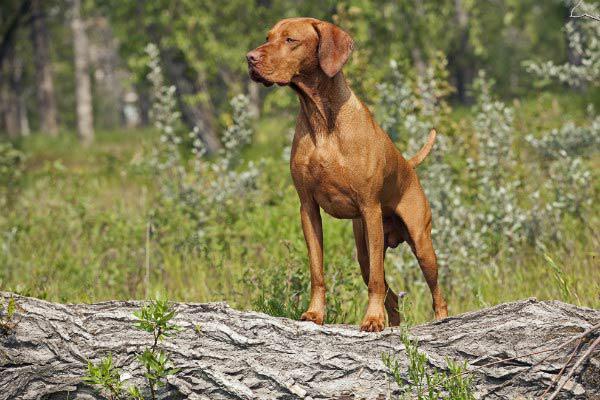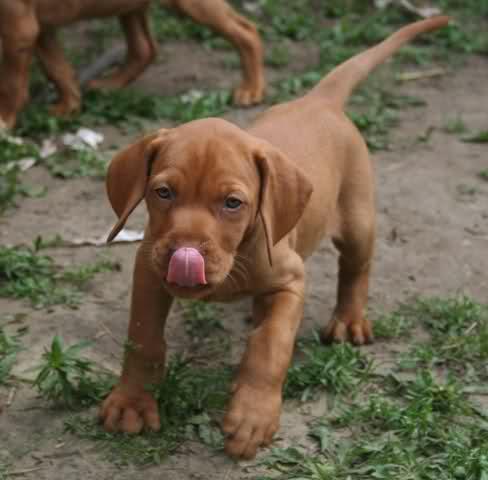The first image is the image on the left, the second image is the image on the right. Considering the images on both sides, is "The dogs in both images are holding one of their paws up off the ground." valid? Answer yes or no. No. The first image is the image on the left, the second image is the image on the right. Considering the images on both sides, is "The dog in the image on the right is standing with a front leg off the ground." valid? Answer yes or no. No. 